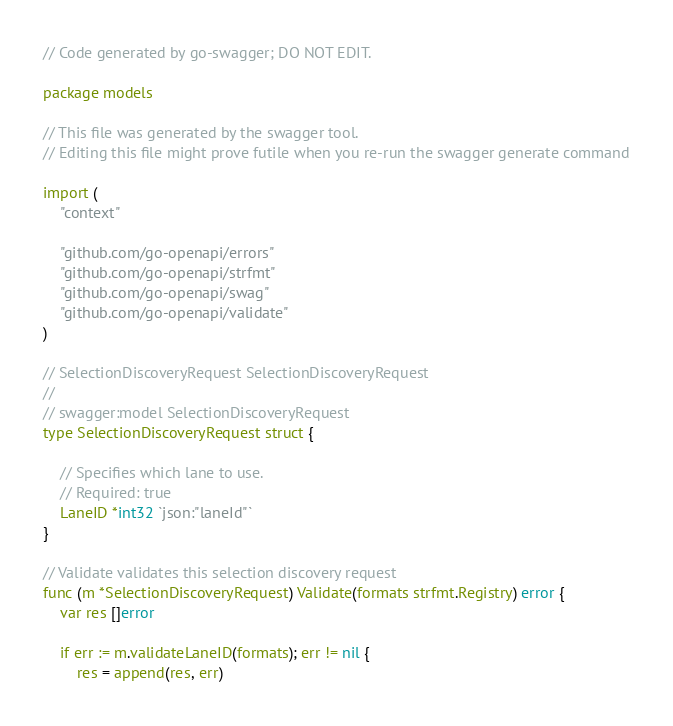Convert code to text. <code><loc_0><loc_0><loc_500><loc_500><_Go_>// Code generated by go-swagger; DO NOT EDIT.

package models

// This file was generated by the swagger tool.
// Editing this file might prove futile when you re-run the swagger generate command

import (
	"context"

	"github.com/go-openapi/errors"
	"github.com/go-openapi/strfmt"
	"github.com/go-openapi/swag"
	"github.com/go-openapi/validate"
)

// SelectionDiscoveryRequest SelectionDiscoveryRequest
//
// swagger:model SelectionDiscoveryRequest
type SelectionDiscoveryRequest struct {

	// Specifies which lane to use.
	// Required: true
	LaneID *int32 `json:"laneId"`
}

// Validate validates this selection discovery request
func (m *SelectionDiscoveryRequest) Validate(formats strfmt.Registry) error {
	var res []error

	if err := m.validateLaneID(formats); err != nil {
		res = append(res, err)</code> 